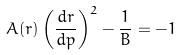<formula> <loc_0><loc_0><loc_500><loc_500>A ( r ) \left ( \frac { d r } { d p } \right ) ^ { 2 } - \frac { 1 } { B } = - 1</formula> 